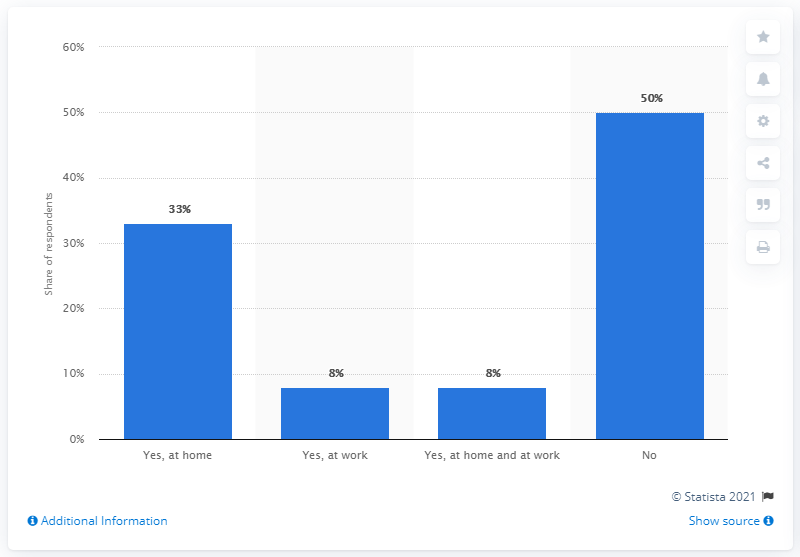Mention a couple of crucial points in this snapshot. The value after division of the longest bar by the shortest bar is 6.25. The value of the blue bar peaked for the group of respondents that the question did not apply to. 